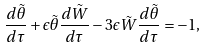<formula> <loc_0><loc_0><loc_500><loc_500>\frac { d \tilde { \theta } } { d \tau } + \epsilon \tilde { \theta } \frac { d \tilde { W } } { d \tau } - 3 \epsilon \tilde { W } \frac { d \tilde { \theta } } { d \tau } = - 1 ,</formula> 